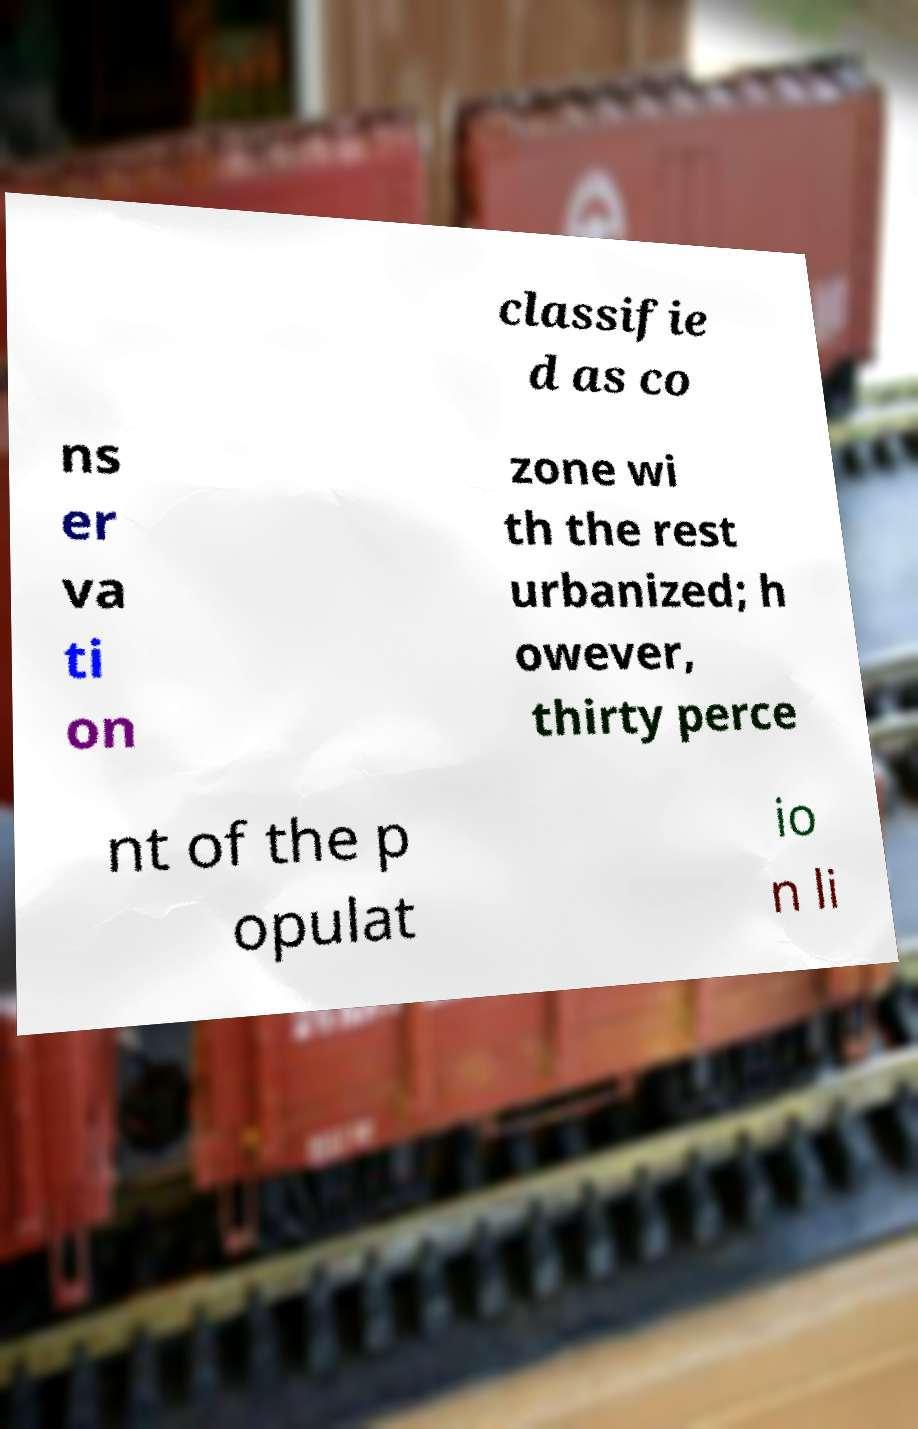Can you read and provide the text displayed in the image?This photo seems to have some interesting text. Can you extract and type it out for me? classifie d as co ns er va ti on zone wi th the rest urbanized; h owever, thirty perce nt of the p opulat io n li 